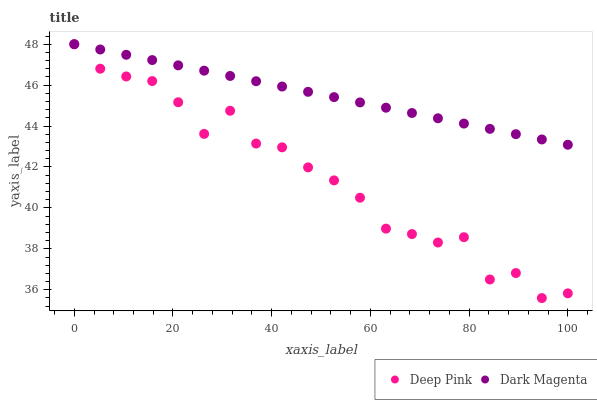Does Deep Pink have the minimum area under the curve?
Answer yes or no. Yes. Does Dark Magenta have the maximum area under the curve?
Answer yes or no. Yes. Does Dark Magenta have the minimum area under the curve?
Answer yes or no. No. Is Dark Magenta the smoothest?
Answer yes or no. Yes. Is Deep Pink the roughest?
Answer yes or no. Yes. Is Dark Magenta the roughest?
Answer yes or no. No. Does Deep Pink have the lowest value?
Answer yes or no. Yes. Does Dark Magenta have the lowest value?
Answer yes or no. No. Does Dark Magenta have the highest value?
Answer yes or no. Yes. Does Dark Magenta intersect Deep Pink?
Answer yes or no. Yes. Is Dark Magenta less than Deep Pink?
Answer yes or no. No. Is Dark Magenta greater than Deep Pink?
Answer yes or no. No. 